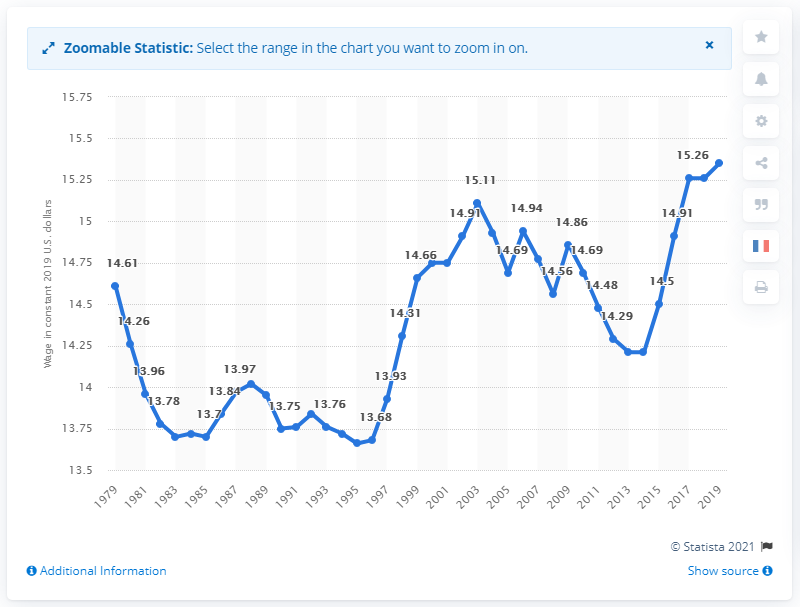Mention a couple of crucial points in this snapshot. In the United States in 2019, the average hourly wage of workers was 15.35 dollars per hour. The value of a worker's wage in 2019 is based on the dollar amount earned by that worker. 